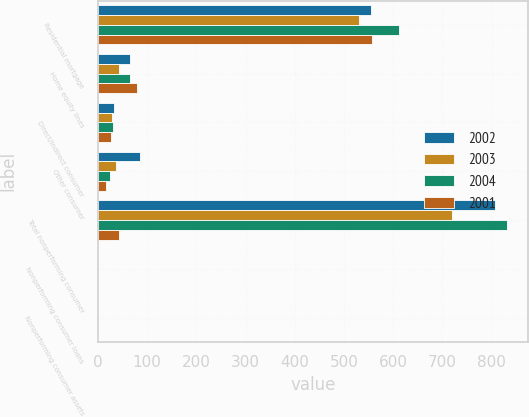Convert chart to OTSL. <chart><loc_0><loc_0><loc_500><loc_500><stacked_bar_chart><ecel><fcel>Residential mortgage<fcel>Home equity lines<fcel>Direct/Indirect consumer<fcel>Other consumer<fcel>Total nonperforming consumer<fcel>Nonperforming consumer loans<fcel>Nonperforming consumer assets<nl><fcel>2002<fcel>554<fcel>66<fcel>33<fcel>85<fcel>807<fcel>0.23<fcel>0.25<nl><fcel>2003<fcel>531<fcel>43<fcel>28<fcel>36<fcel>719<fcel>0.27<fcel>0.3<nl><fcel>2004<fcel>612<fcel>66<fcel>30<fcel>25<fcel>832<fcel>0.37<fcel>0.42<nl><fcel>2001<fcel>556<fcel>80<fcel>27<fcel>16<fcel>43<fcel>0.41<fcel>0.61<nl></chart> 